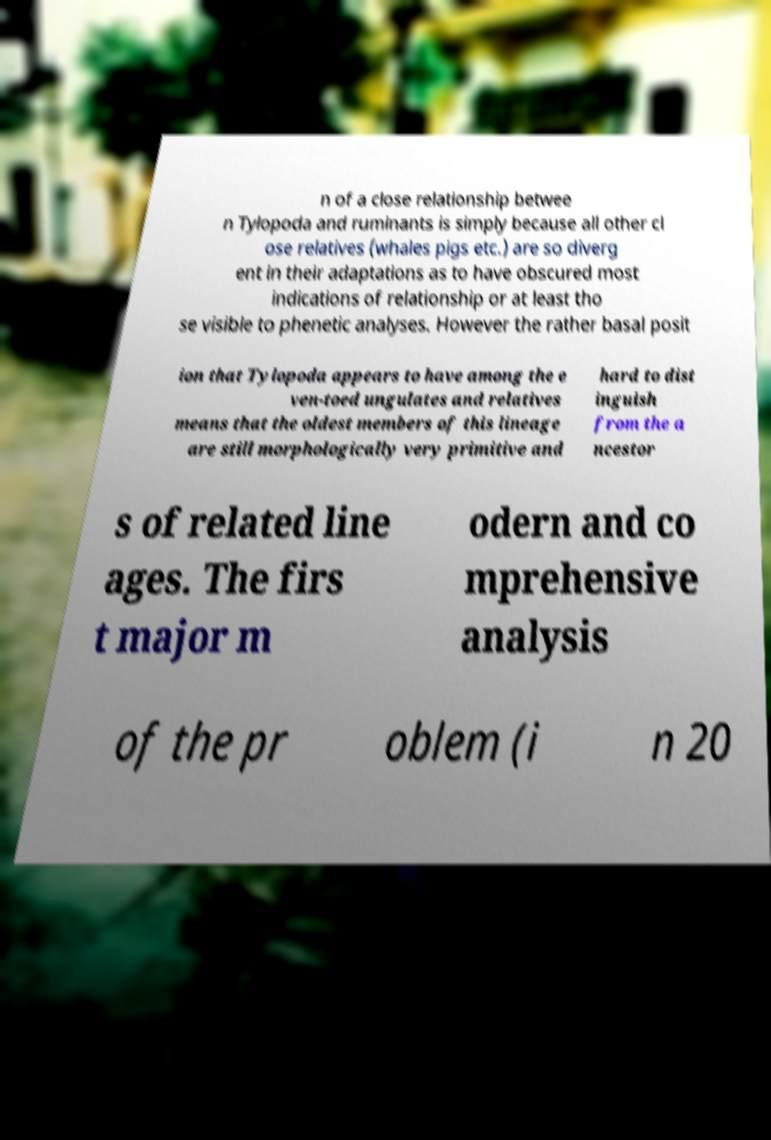Please identify and transcribe the text found in this image. n of a close relationship betwee n Tylopoda and ruminants is simply because all other cl ose relatives (whales pigs etc.) are so diverg ent in their adaptations as to have obscured most indications of relationship or at least tho se visible to phenetic analyses. However the rather basal posit ion that Tylopoda appears to have among the e ven-toed ungulates and relatives means that the oldest members of this lineage are still morphologically very primitive and hard to dist inguish from the a ncestor s of related line ages. The firs t major m odern and co mprehensive analysis of the pr oblem (i n 20 